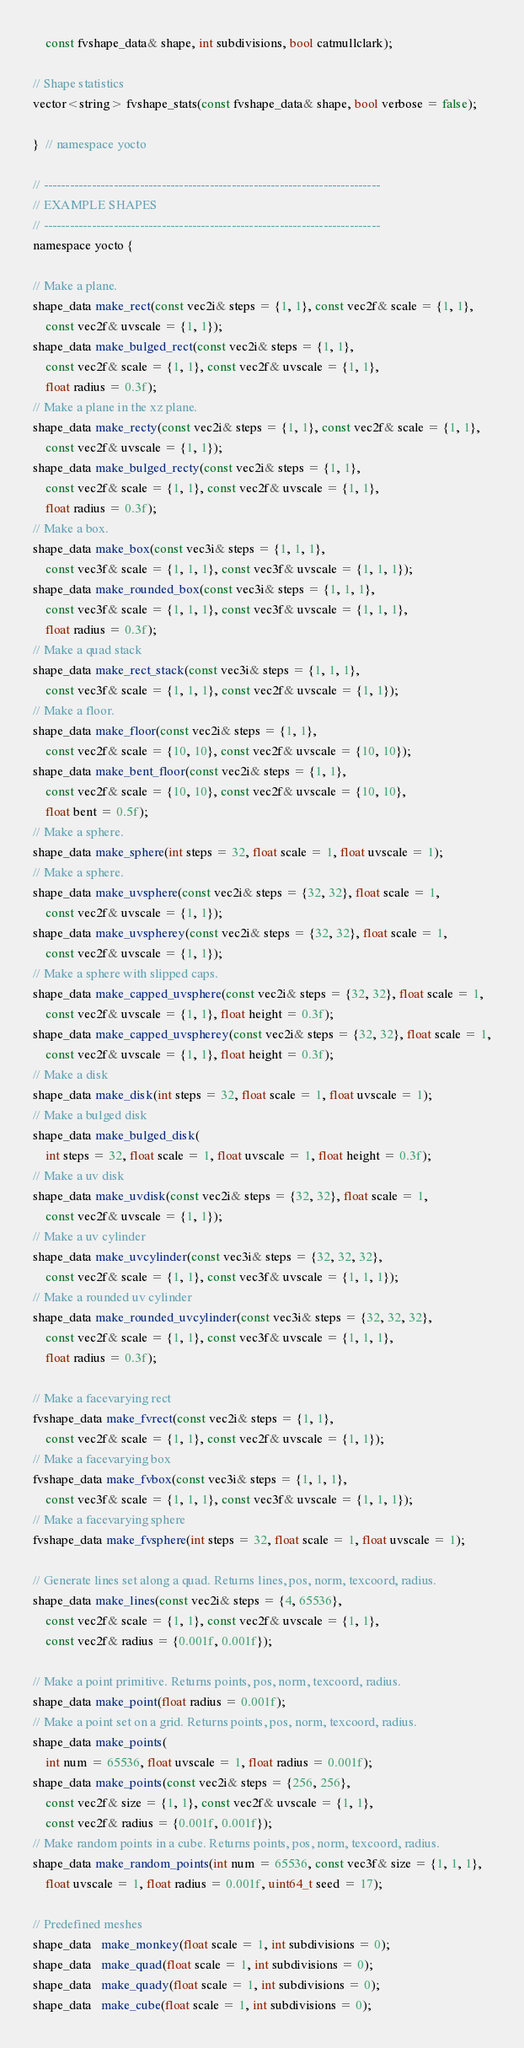<code> <loc_0><loc_0><loc_500><loc_500><_C_>    const fvshape_data& shape, int subdivisions, bool catmullclark);

// Shape statistics
vector<string> fvshape_stats(const fvshape_data& shape, bool verbose = false);

}  // namespace yocto

// -----------------------------------------------------------------------------
// EXAMPLE SHAPES
// -----------------------------------------------------------------------------
namespace yocto {

// Make a plane.
shape_data make_rect(const vec2i& steps = {1, 1}, const vec2f& scale = {1, 1},
    const vec2f& uvscale = {1, 1});
shape_data make_bulged_rect(const vec2i& steps = {1, 1},
    const vec2f& scale = {1, 1}, const vec2f& uvscale = {1, 1},
    float radius = 0.3f);
// Make a plane in the xz plane.
shape_data make_recty(const vec2i& steps = {1, 1}, const vec2f& scale = {1, 1},
    const vec2f& uvscale = {1, 1});
shape_data make_bulged_recty(const vec2i& steps = {1, 1},
    const vec2f& scale = {1, 1}, const vec2f& uvscale = {1, 1},
    float radius = 0.3f);
// Make a box.
shape_data make_box(const vec3i& steps = {1, 1, 1},
    const vec3f& scale = {1, 1, 1}, const vec3f& uvscale = {1, 1, 1});
shape_data make_rounded_box(const vec3i& steps = {1, 1, 1},
    const vec3f& scale = {1, 1, 1}, const vec3f& uvscale = {1, 1, 1},
    float radius = 0.3f);
// Make a quad stack
shape_data make_rect_stack(const vec3i& steps = {1, 1, 1},
    const vec3f& scale = {1, 1, 1}, const vec2f& uvscale = {1, 1});
// Make a floor.
shape_data make_floor(const vec2i& steps = {1, 1},
    const vec2f& scale = {10, 10}, const vec2f& uvscale = {10, 10});
shape_data make_bent_floor(const vec2i& steps = {1, 1},
    const vec2f& scale = {10, 10}, const vec2f& uvscale = {10, 10},
    float bent = 0.5f);
// Make a sphere.
shape_data make_sphere(int steps = 32, float scale = 1, float uvscale = 1);
// Make a sphere.
shape_data make_uvsphere(const vec2i& steps = {32, 32}, float scale = 1,
    const vec2f& uvscale = {1, 1});
shape_data make_uvspherey(const vec2i& steps = {32, 32}, float scale = 1,
    const vec2f& uvscale = {1, 1});
// Make a sphere with slipped caps.
shape_data make_capped_uvsphere(const vec2i& steps = {32, 32}, float scale = 1,
    const vec2f& uvscale = {1, 1}, float height = 0.3f);
shape_data make_capped_uvspherey(const vec2i& steps = {32, 32}, float scale = 1,
    const vec2f& uvscale = {1, 1}, float height = 0.3f);
// Make a disk
shape_data make_disk(int steps = 32, float scale = 1, float uvscale = 1);
// Make a bulged disk
shape_data make_bulged_disk(
    int steps = 32, float scale = 1, float uvscale = 1, float height = 0.3f);
// Make a uv disk
shape_data make_uvdisk(const vec2i& steps = {32, 32}, float scale = 1,
    const vec2f& uvscale = {1, 1});
// Make a uv cylinder
shape_data make_uvcylinder(const vec3i& steps = {32, 32, 32},
    const vec2f& scale = {1, 1}, const vec3f& uvscale = {1, 1, 1});
// Make a rounded uv cylinder
shape_data make_rounded_uvcylinder(const vec3i& steps = {32, 32, 32},
    const vec2f& scale = {1, 1}, const vec3f& uvscale = {1, 1, 1},
    float radius = 0.3f);

// Make a facevarying rect
fvshape_data make_fvrect(const vec2i& steps = {1, 1},
    const vec2f& scale = {1, 1}, const vec2f& uvscale = {1, 1});
// Make a facevarying box
fvshape_data make_fvbox(const vec3i& steps = {1, 1, 1},
    const vec3f& scale = {1, 1, 1}, const vec3f& uvscale = {1, 1, 1});
// Make a facevarying sphere
fvshape_data make_fvsphere(int steps = 32, float scale = 1, float uvscale = 1);

// Generate lines set along a quad. Returns lines, pos, norm, texcoord, radius.
shape_data make_lines(const vec2i& steps = {4, 65536},
    const vec2f& scale = {1, 1}, const vec2f& uvscale = {1, 1},
    const vec2f& radius = {0.001f, 0.001f});

// Make a point primitive. Returns points, pos, norm, texcoord, radius.
shape_data make_point(float radius = 0.001f);
// Make a point set on a grid. Returns points, pos, norm, texcoord, radius.
shape_data make_points(
    int num = 65536, float uvscale = 1, float radius = 0.001f);
shape_data make_points(const vec2i& steps = {256, 256},
    const vec2f& size = {1, 1}, const vec2f& uvscale = {1, 1},
    const vec2f& radius = {0.001f, 0.001f});
// Make random points in a cube. Returns points, pos, norm, texcoord, radius.
shape_data make_random_points(int num = 65536, const vec3f& size = {1, 1, 1},
    float uvscale = 1, float radius = 0.001f, uint64_t seed = 17);

// Predefined meshes
shape_data   make_monkey(float scale = 1, int subdivisions = 0);
shape_data   make_quad(float scale = 1, int subdivisions = 0);
shape_data   make_quady(float scale = 1, int subdivisions = 0);
shape_data   make_cube(float scale = 1, int subdivisions = 0);</code> 